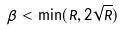Convert formula to latex. <formula><loc_0><loc_0><loc_500><loc_500>\beta < \min ( R , 2 \sqrt { R } )</formula> 